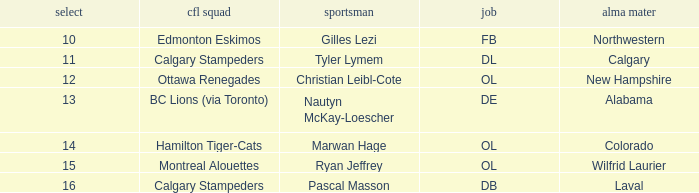What is the pick number for Northwestern college? 10.0. 